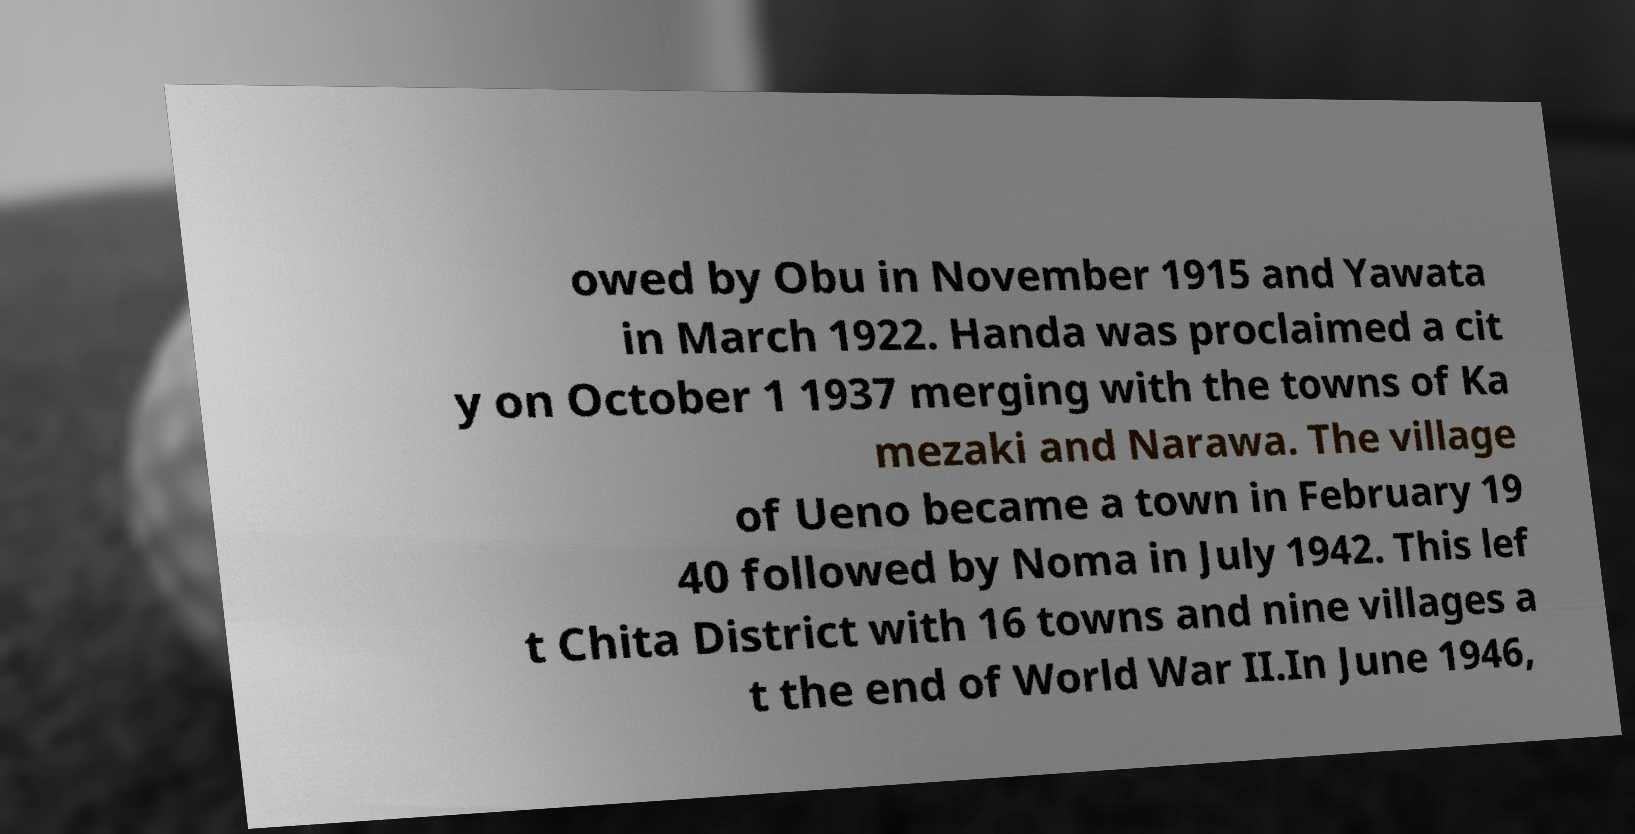Can you accurately transcribe the text from the provided image for me? owed by Obu in November 1915 and Yawata in March 1922. Handa was proclaimed a cit y on October 1 1937 merging with the towns of Ka mezaki and Narawa. The village of Ueno became a town in February 19 40 followed by Noma in July 1942. This lef t Chita District with 16 towns and nine villages a t the end of World War II.In June 1946, 